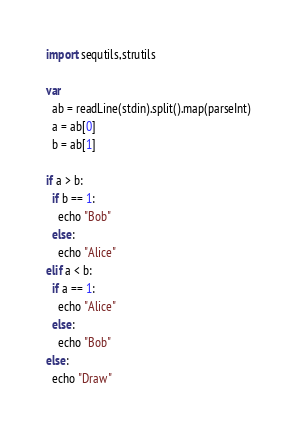<code> <loc_0><loc_0><loc_500><loc_500><_Nim_>import sequtils,strutils

var
  ab = readLine(stdin).split().map(parseInt)
  a = ab[0]
  b = ab[1]

if a > b:
  if b == 1:
    echo "Bob"
  else:
    echo "Alice"
elif a < b:
  if a == 1:
    echo "Alice"
  else:
    echo "Bob"
else:
  echo "Draw"</code> 